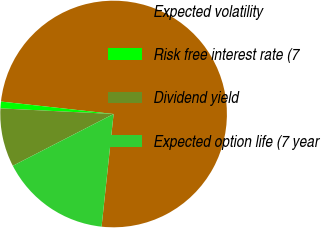<chart> <loc_0><loc_0><loc_500><loc_500><pie_chart><fcel>Expected volatility<fcel>Risk free interest rate (7<fcel>Dividend yield<fcel>Expected option life (7 year<nl><fcel>74.94%<fcel>0.96%<fcel>8.35%<fcel>15.75%<nl></chart> 